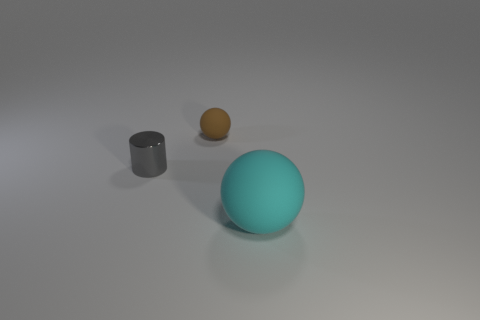Add 3 green blocks. How many objects exist? 6 Subtract all spheres. How many objects are left? 1 Subtract 0 purple balls. How many objects are left? 3 Subtract all green spheres. Subtract all red cubes. How many spheres are left? 2 Subtract all yellow cubes. How many cyan balls are left? 1 Subtract all metal objects. Subtract all tiny cyan cubes. How many objects are left? 2 Add 2 large things. How many large things are left? 3 Add 2 small gray things. How many small gray things exist? 3 